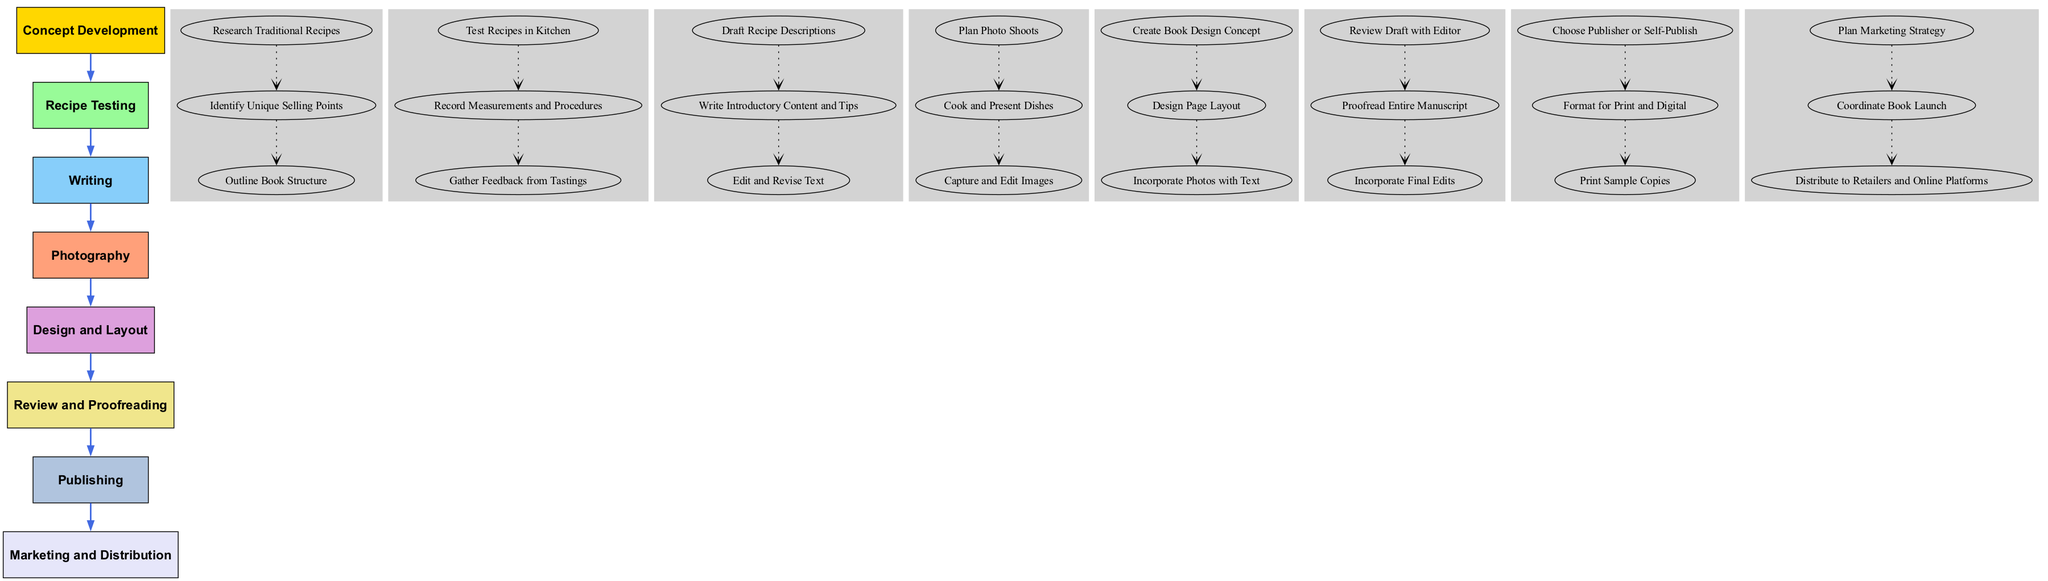What is the first stage in the workflow? The first stage listed in the diagram is "Concept Development." This is found at the top of the workflow, which outlines the sequential steps involved in writing and publishing a cookbook.
Answer: Concept Development How many steps are there in the "Recipe Testing" stage? The "Recipe Testing" stage includes three steps: "Test Recipes in Kitchen," "Record Measurements and Procedures," and "Gather Feedback from Tastings." This can be counted directly from the diagram.
Answer: 3 What connects the "Photography" stage to the "Design and Layout" stage? The connection between the "Photography" stage and the "Design and Layout" stage is a bold edge arrow, indicating the direct flow of the process from one stage to the next in the workflow.
Answer: Bold edge arrow Which stage involves creating a book design concept? The stage that involves creating a book design concept is "Design and Layout." This can be identified by looking at the respective steps listed under that stage in the diagram.
Answer: Design and Layout How many total stages are present in this workflow? There are eight distinct stages present in the workflow: "Concept Development," "Recipe Testing," "Writing," "Photography," "Design and Layout," "Review and Proofreading," "Publishing," and "Marketing and Distribution." This total can be determined by counting the unique stages outlined in the diagram.
Answer: 8 What is the final step mentioned under the "Marketing and Distribution" stage? The final step listed under the "Marketing and Distribution" stage is "Distribute to Retailers and Online Platforms." This is the last point in that flow and can be found by reviewing the steps highlighted in that stage.
Answer: Distribute to Retailers and Online Platforms How does "Review and Proofreading" relate to "Recipe Testing"? "Review and Proofreading" comes after "Recipe Testing" in the workflow, establishing a sequential relationship where insights from "Recipe Testing" likely inform the revisions made in "Review and Proofreading." The diagram uses a bold arrow to illustrate this connection.
Answer: Sequential relationship What determines the choice between publisher or self-publish in the workflow? The choice between publisher or self-publish is determined in the "Publishing" stage. This is the first step under that stage and clearly indicates a decision point that influences the following steps.
Answer: Choose Publisher or Self-Publish 